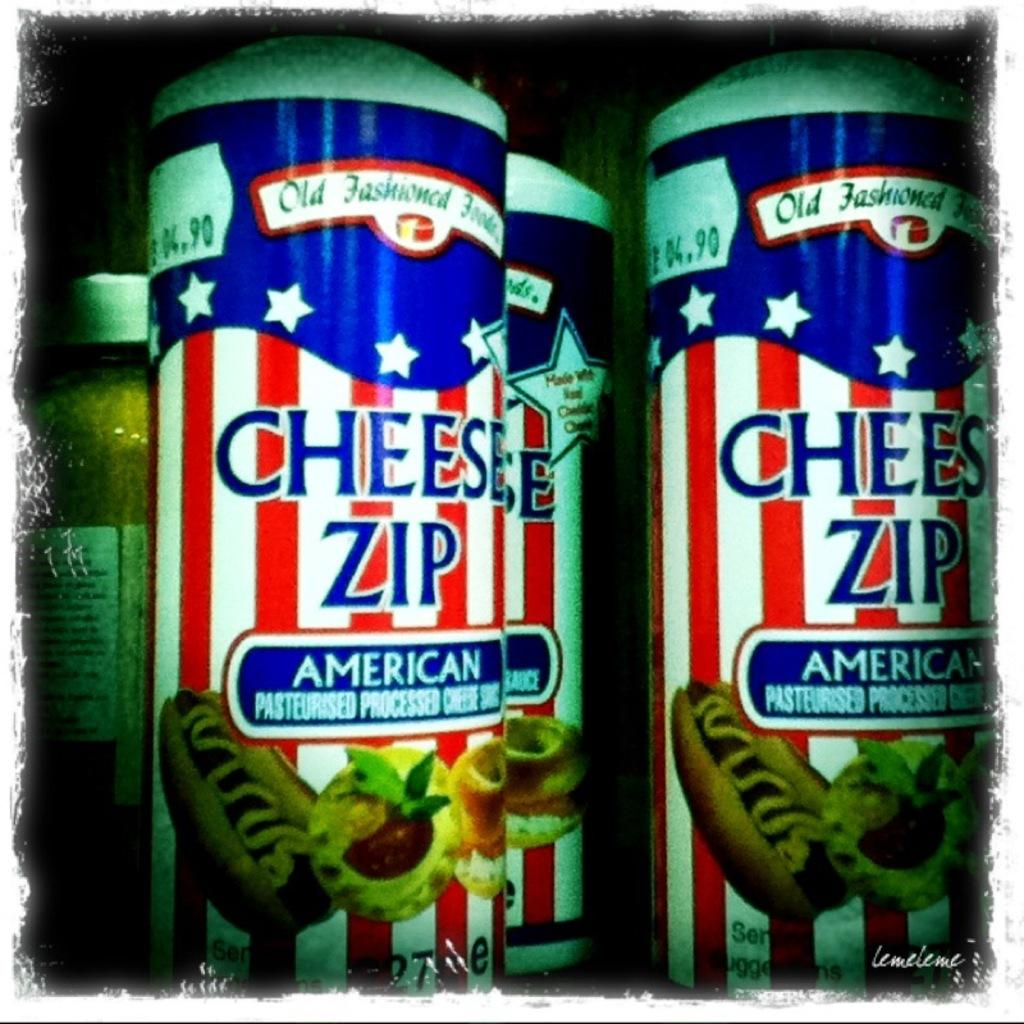<image>
Give a short and clear explanation of the subsequent image. A shelf has three cans that say Cheese Zip on them. 